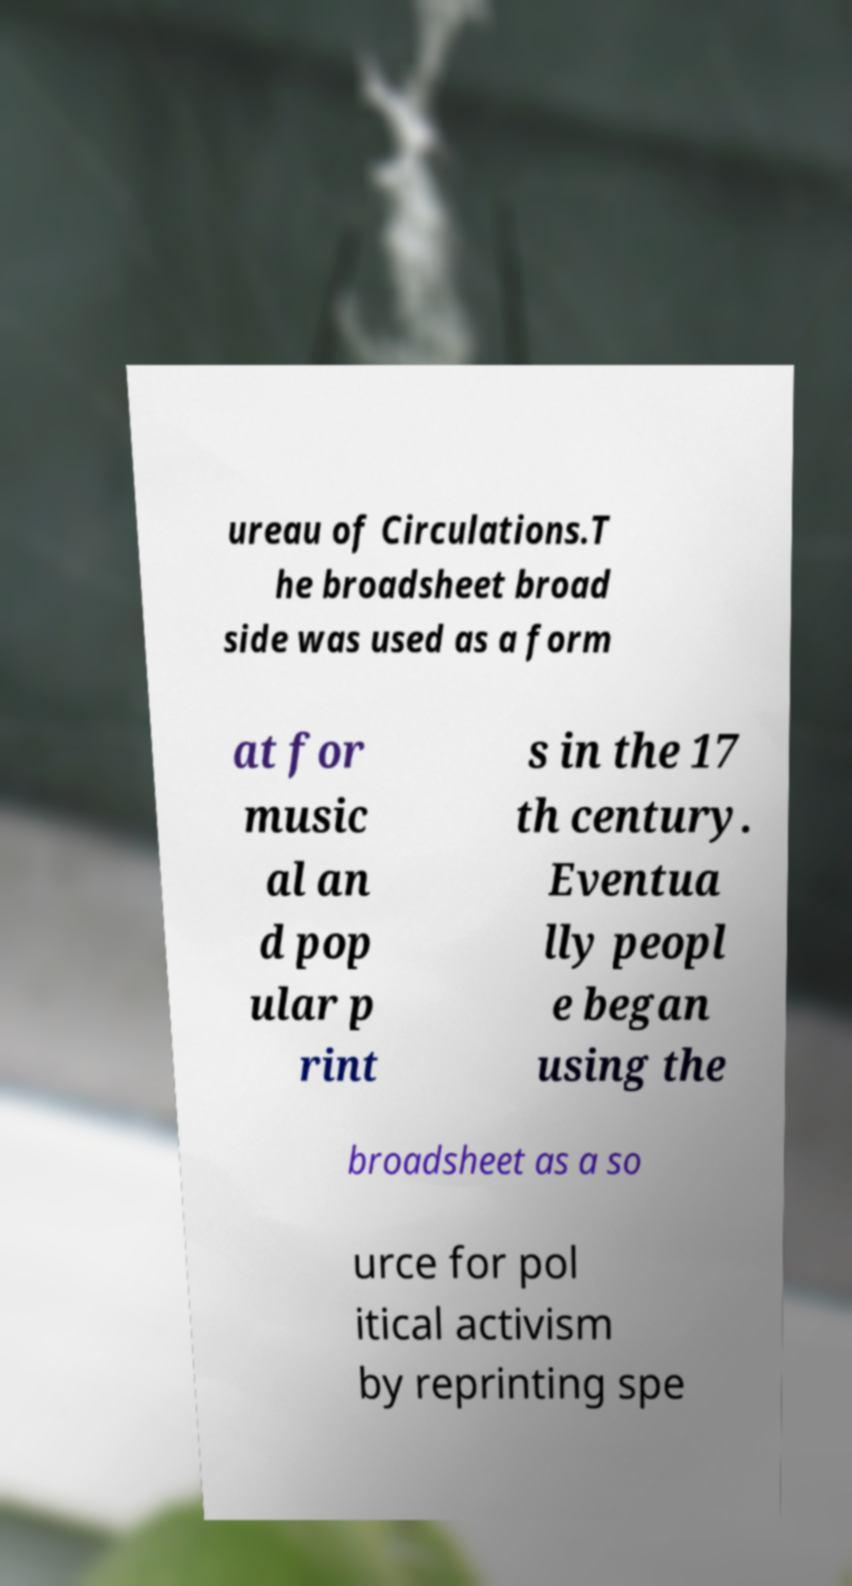Please identify and transcribe the text found in this image. ureau of Circulations.T he broadsheet broad side was used as a form at for music al an d pop ular p rint s in the 17 th century. Eventua lly peopl e began using the broadsheet as a so urce for pol itical activism by reprinting spe 